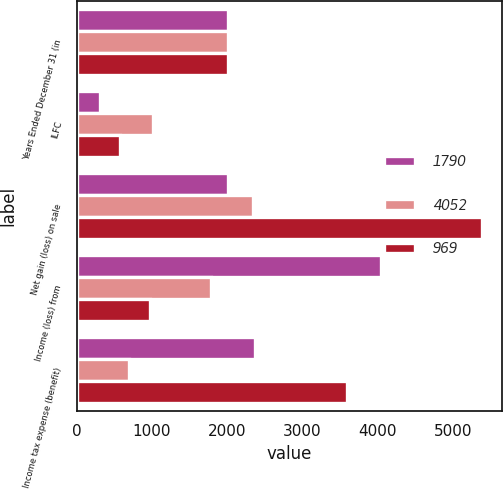<chart> <loc_0><loc_0><loc_500><loc_500><stacked_bar_chart><ecel><fcel>Years Ended December 31 (in<fcel>ILFC<fcel>Net gain (loss) on sale<fcel>Income (loss) from<fcel>Income tax expense (benefit)<nl><fcel>1790<fcel>2012<fcel>304<fcel>2012<fcel>4052<fcel>2377<nl><fcel>4052<fcel>2011<fcel>1017<fcel>2338<fcel>1790<fcel>698<nl><fcel>969<fcel>2010<fcel>581<fcel>5389<fcel>969<fcel>3599<nl></chart> 